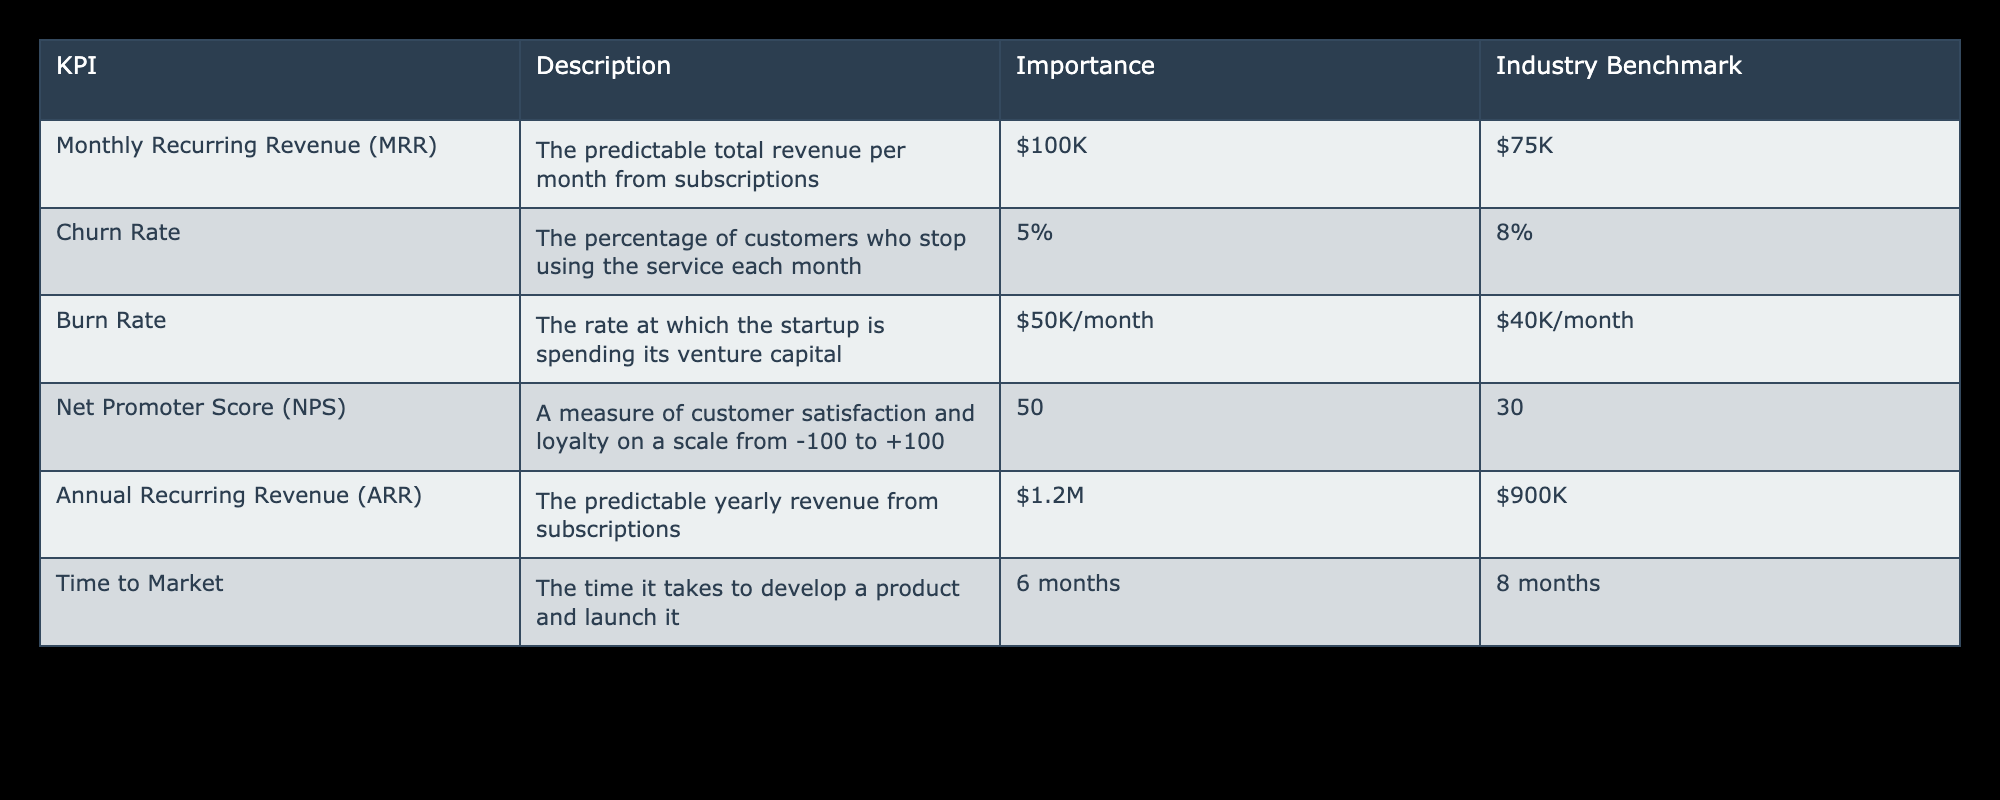What is the Monthly Recurring Revenue (MRR) for the startup? The table states that the Monthly Recurring Revenue (MRR) for the startup is $100K.
Answer: $100K What is the Churn Rate according to the table? The table indicates that the Churn Rate, which is the percentage of customers who stop using the service each month, is 5%.
Answer: 5% Is the Net Promoter Score (NPS) greater than the Industry Benchmark? The table shows that the NPS for the startup is 50, while the Industry Benchmark is 30. Since 50 is greater than 30, the answer is yes.
Answer: Yes What is the difference between the startup's Annual Recurring Revenue (ARR) and the Industry Benchmark? The startup's ARR is $1.2M and the Industry Benchmark for ARR is $900K. The difference is calculated as $1.2M - $900K = $300K.
Answer: $300K Does the startup’s burn rate exceed the Industry Benchmark? The table lists the startup's burn rate as $50K/month and the Industry Benchmark as $40K/month. Since $50K is greater than $40K, the answer is yes.
Answer: Yes What is the average time to market when compared to the industry benchmark? The startup has a time to market of 6 months, while the industry benchmark is 8 months. The average can be calculated as (6 + 8)/2 = 7 months.
Answer: 7 months How much more revenue does the startup generate monthly compared to the Industry Benchmark for MRR? The startup has an MRR of $100K and the Industry Benchmark is $75K. The difference is calculated as $100K - $75K = $25K.
Answer: $25K What is the total annual revenue based on the startup's MRR? To find the total annual revenue from MRR, multiply the MRR of $100K by 12 months. Therefore, $100K * 12 = $1.2M.
Answer: $1.2M What percentage does the startup’s burn rate represent over its MRR? The burn rate is $50K, and the MRR is $100K. The ratio is calculated as ($50K / $100K) * 100 = 50%.
Answer: 50% 